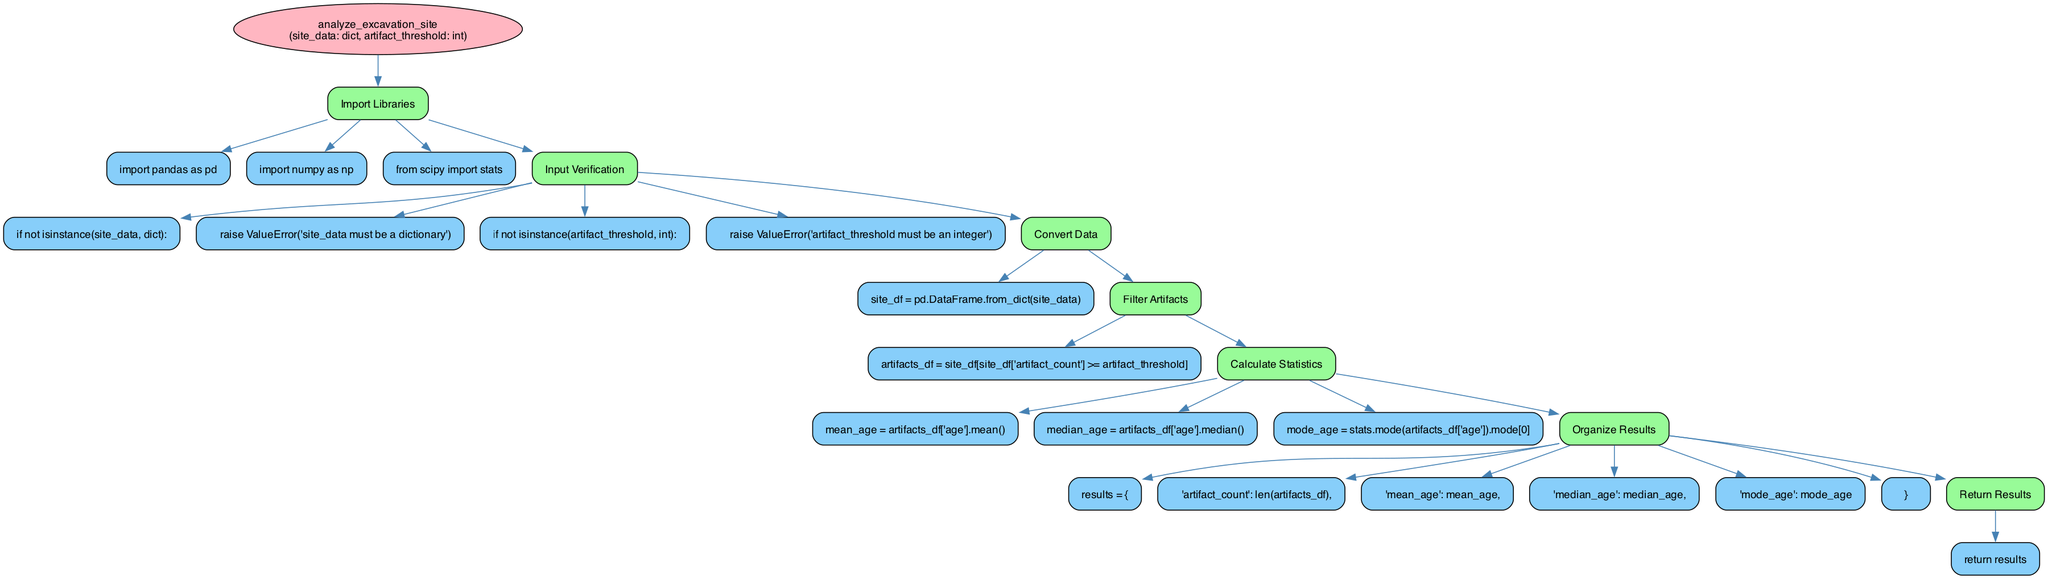What is the name of the function in the diagram? The name of the function is displayed prominently within an ellipse at the top of the diagram. It is labeled as "analyze_excavation_site".
Answer: analyze_excavation_site How many steps are there in the function? The diagram contains a total of six steps. By counting the number of boxes labeled with "step" in the flowchart, we arrive at this number.
Answer: 6 What type of data is expected for 'site_data'? According to the 'Input Verification' step in the diagram, the function checks if 'site_data' is a dictionary. This is stated in the conditional check for 'site_data'.
Answer: dictionary What is the first action in the 'Convert Data' step? The first action under 'Convert Data' is "site_df = pd.DataFrame.from_dict(site_data)". This is the only action listed in this step.
Answer: site_df = pd.DataFrame.from_dict(site_data) Which step follows 'Filter Artifacts'? The next step after 'Filter Artifacts' in the flowchart is 'Calculate Statistics'. This can be determined by following the flow of edges that connect the steps sequentially.
Answer: Calculate Statistics What is the output of the function? The 'Return Results' step indicates that the function outputs a dictionary named 'results' containing several key statistics from the analysis, including 'artifact_count', 'mean_age', 'median_age', and 'mode_age'.
Answer: results Which library is imported to calculate statistics? The 'Calculate Statistics' step uses 'stats' from the 'scipy' library. This is reflected in the 'Import Libraries' step where it is listed as one of the imports.
Answer: scipy Why is there a check for 'artifact_threshold'? The function includes an input verification check for 'artifact_threshold' to ensure that it is an integer, which is important for the subsequent filtering of artifacts based on this threshold. This prevents runtime errors if incorrect types are provided.
Answer: To ensure it is an integer What must be ensured before proceeding to 'Convert Data'? Before proceeding to 'Convert Data', the function must ensure that 'site_data' is a dictionary and 'artifact_threshold' is an integer. This is a crucial prerequisite step to avoid errors during data manipulation.
Answer: Valid input types 